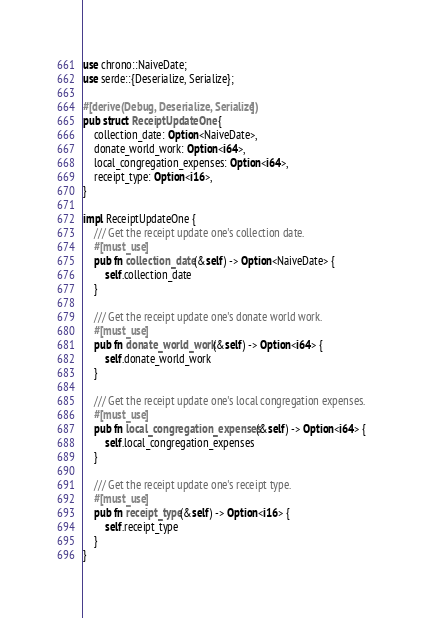<code> <loc_0><loc_0><loc_500><loc_500><_Rust_>use chrono::NaiveDate;
use serde::{Deserialize, Serialize};

#[derive(Debug, Deserialize, Serialize)]
pub struct ReceiptUpdateOne {
    collection_date: Option<NaiveDate>,
    donate_world_work: Option<i64>,
    local_congregation_expenses: Option<i64>,
    receipt_type: Option<i16>,
}

impl ReceiptUpdateOne {
    /// Get the receipt update one's collection date.
    #[must_use]
    pub fn collection_date(&self) -> Option<NaiveDate> {
        self.collection_date
    }

    /// Get the receipt update one's donate world work.
    #[must_use]
    pub fn donate_world_work(&self) -> Option<i64> {
        self.donate_world_work
    }

    /// Get the receipt update one's local congregation expenses.
    #[must_use]
    pub fn local_congregation_expenses(&self) -> Option<i64> {
        self.local_congregation_expenses
    }

    /// Get the receipt update one's receipt type.
    #[must_use]
    pub fn receipt_type(&self) -> Option<i16> {
        self.receipt_type
    }
}
</code> 